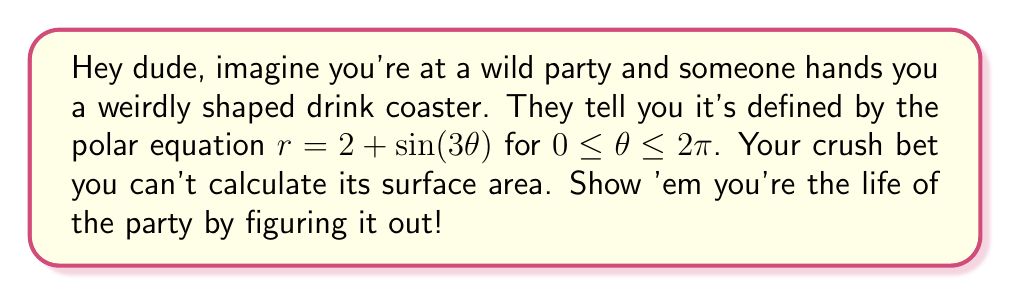Show me your answer to this math problem. Alright, let's tackle this step by step:

1) The formula for the surface area of a shape defined by polar coordinates is:

   $$ A = \frac{1}{2} \int_a^b r^2 d\theta $$

   where $r$ is the polar function and $[a,b]$ is the interval for $\theta$.

2) In our case, $r = 2 + \sin(3\theta)$ and the interval is $[0, 2\pi]$. Let's plug this in:

   $$ A = \frac{1}{2} \int_0^{2\pi} (2 + \sin(3\theta))^2 d\theta $$

3) Expand the squared term:

   $$ A = \frac{1}{2} \int_0^{2\pi} (4 + 4\sin(3\theta) + \sin^2(3\theta)) d\theta $$

4) Split the integral:

   $$ A = \frac{1}{2} \int_0^{2\pi} 4 d\theta + \frac{1}{2} \int_0^{2\pi} 4\sin(3\theta) d\theta + \frac{1}{2} \int_0^{2\pi} \sin^2(3\theta) d\theta $$

5) Evaluate each integral:
   - $\int_0^{2\pi} 4 d\theta = 4\theta \big|_0^{2\pi} = 8\pi$
   - $\int_0^{2\pi} 4\sin(3\theta) d\theta = -\frac{4}{3}\cos(3\theta) \big|_0^{2\pi} = 0$
   - For the last integral, use the identity $\sin^2 x = \frac{1}{2}(1 - \cos(2x))$:
     $\int_0^{2\pi} \sin^2(3\theta) d\theta = \int_0^{2\pi} \frac{1}{2}(1 - \cos(6\theta)) d\theta = \pi - 0 = \pi$

6) Sum up the results:

   $$ A = \frac{1}{2}(8\pi + 0 + \pi) = \frac{9\pi}{2} $$

Thus, the surface area of the coaster is $\frac{9\pi}{2}$ square units.
Answer: $\frac{9\pi}{2}$ square units 